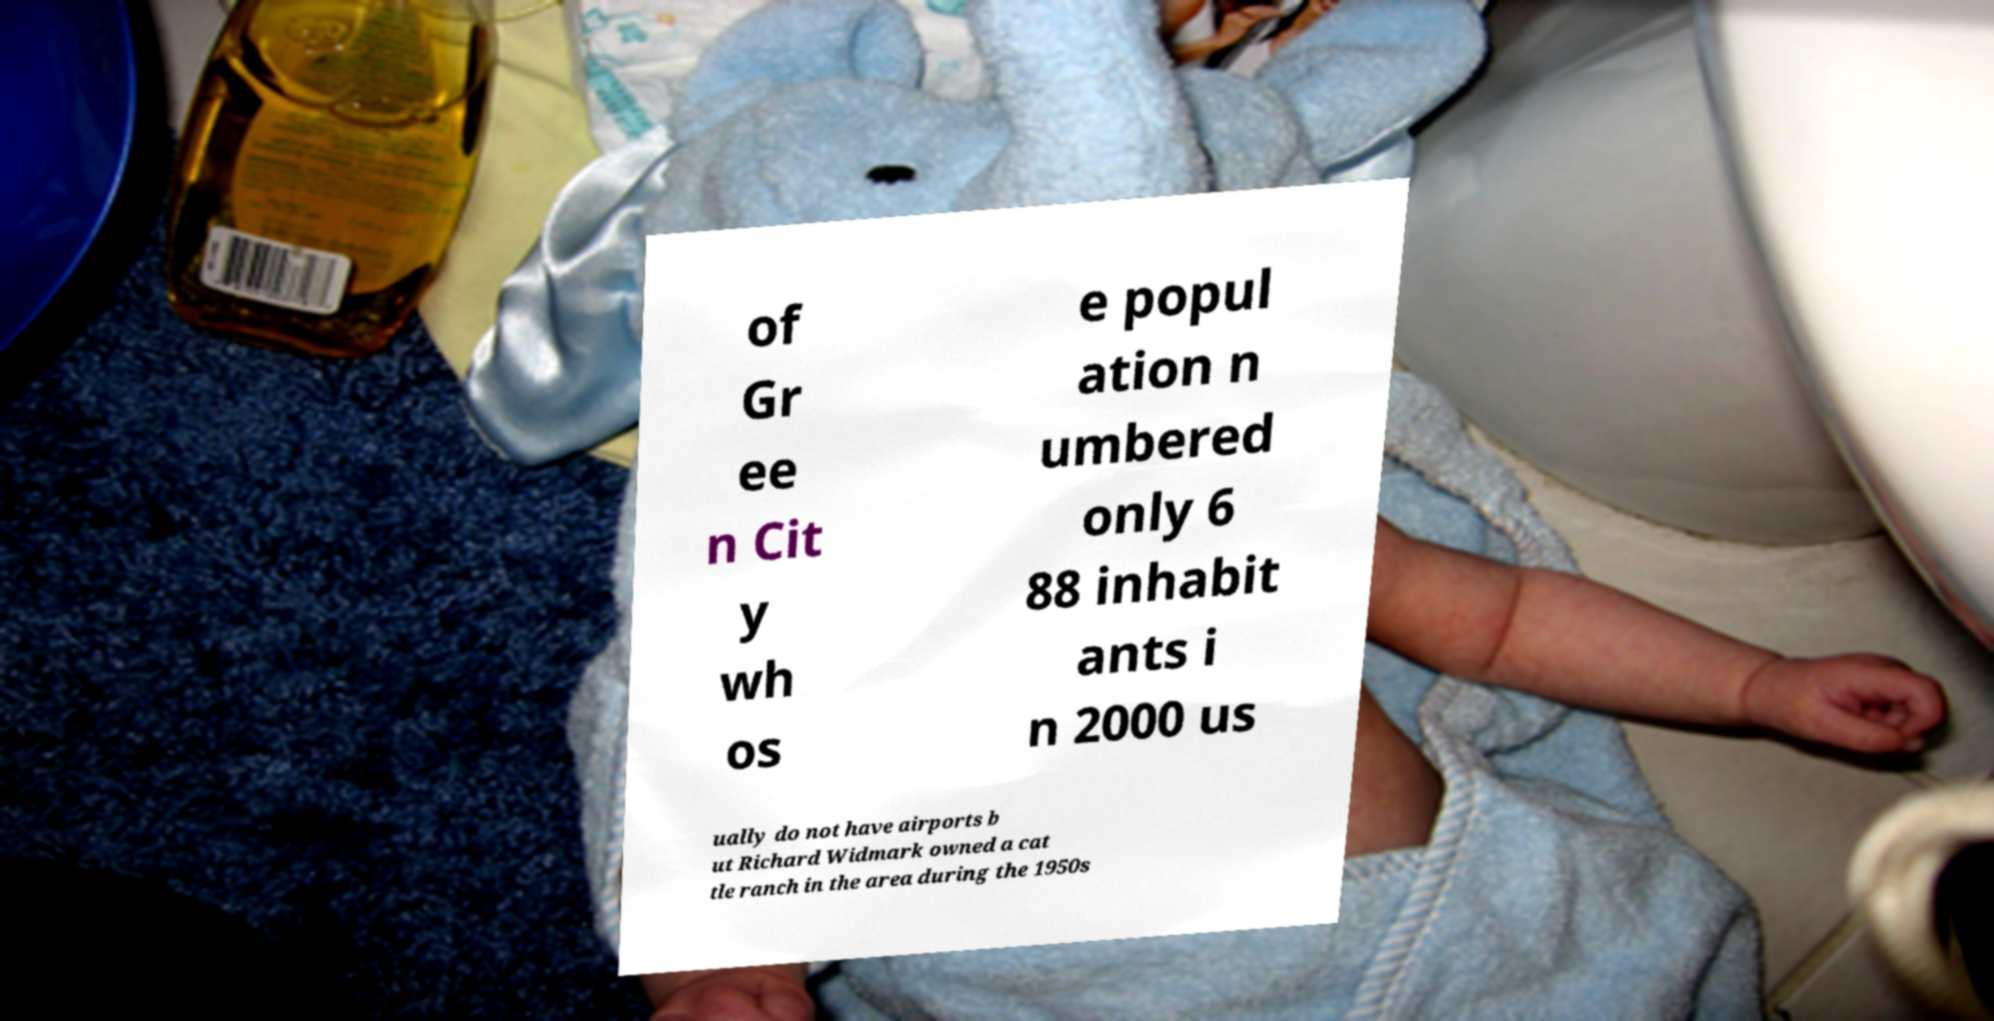Please identify and transcribe the text found in this image. of Gr ee n Cit y wh os e popul ation n umbered only 6 88 inhabit ants i n 2000 us ually do not have airports b ut Richard Widmark owned a cat tle ranch in the area during the 1950s 